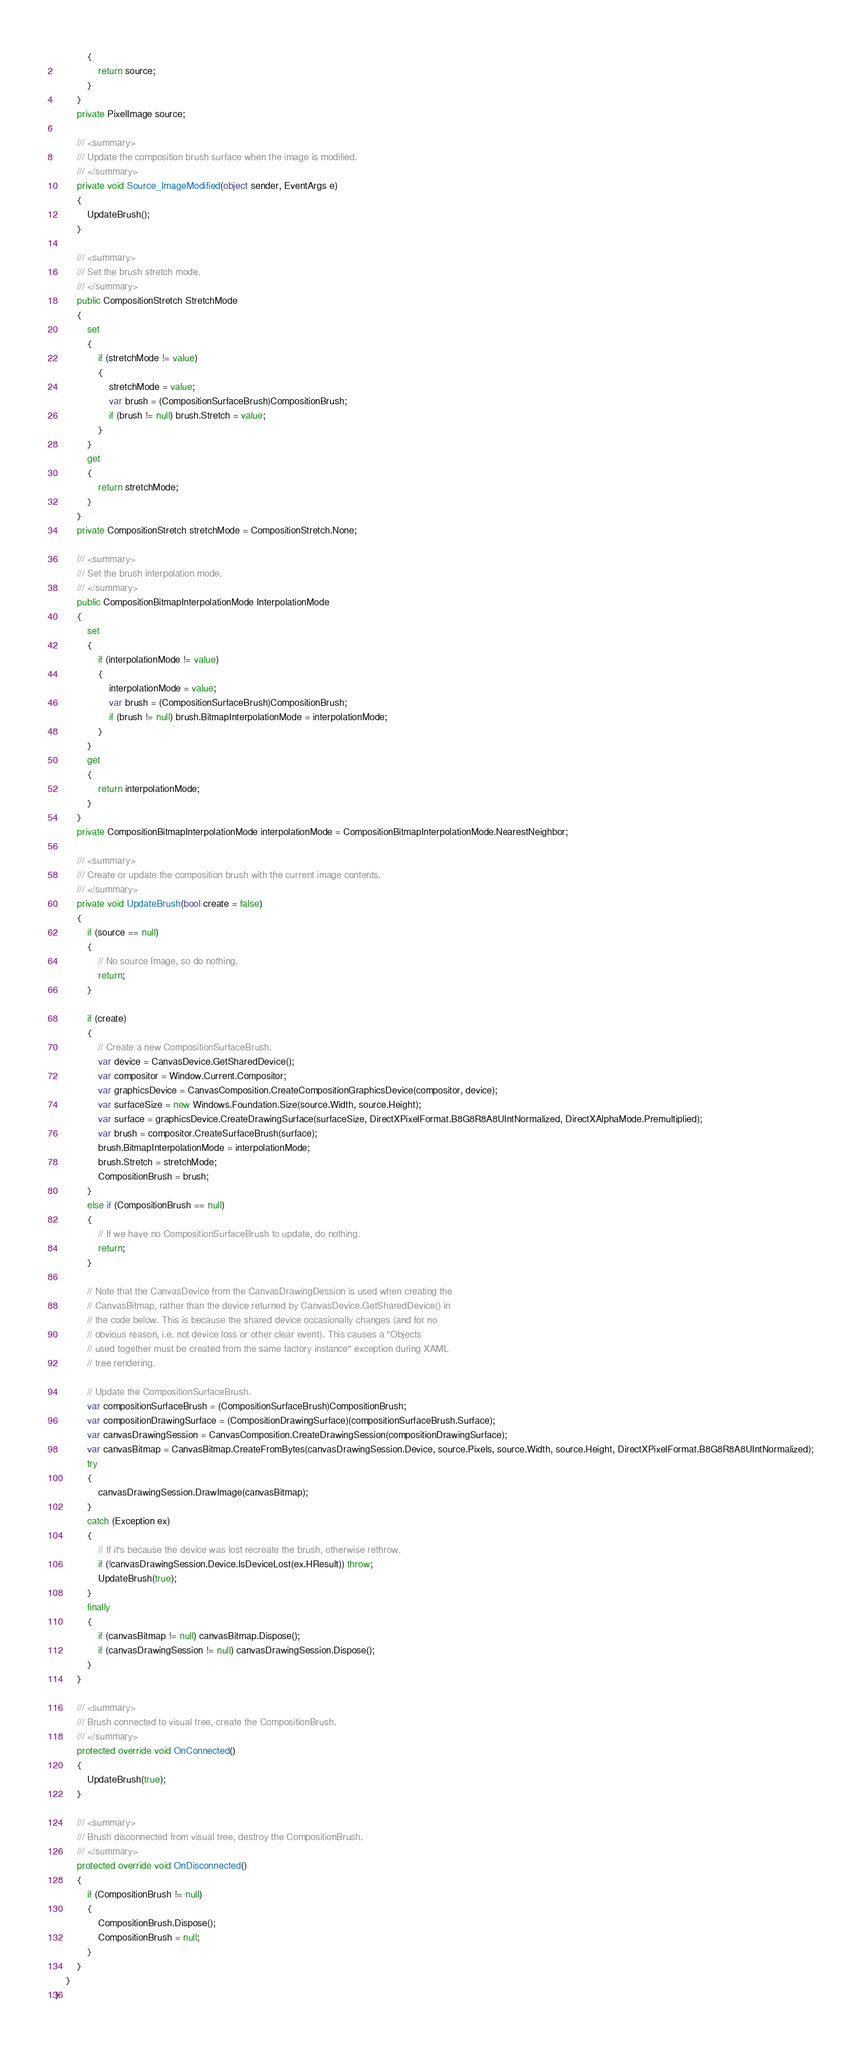<code> <loc_0><loc_0><loc_500><loc_500><_C#_>            {
                return source;
            }
        }
        private PixelImage source;

        /// <summary>
        /// Update the composition brush surface when the image is modified.
        /// </summary>
        private void Source_ImageModified(object sender, EventArgs e)
        {
            UpdateBrush();
        }

        /// <summary>
        /// Set the brush stretch mode.
        /// </summary>
        public CompositionStretch StretchMode
        {
            set
            {
                if (stretchMode != value)
                {
                    stretchMode = value;
                    var brush = (CompositionSurfaceBrush)CompositionBrush;
                    if (brush != null) brush.Stretch = value;
                }
            }
            get
            {
                return stretchMode;
            }
        }
        private CompositionStretch stretchMode = CompositionStretch.None;

        /// <summary>
        /// Set the brush interpolation mode.
        /// </summary>
        public CompositionBitmapInterpolationMode InterpolationMode
        {
            set
            {
                if (interpolationMode != value)
                {
                    interpolationMode = value;
                    var brush = (CompositionSurfaceBrush)CompositionBrush;
                    if (brush != null) brush.BitmapInterpolationMode = interpolationMode;
                }
            }
            get
            {
                return interpolationMode;
            }
        }
        private CompositionBitmapInterpolationMode interpolationMode = CompositionBitmapInterpolationMode.NearestNeighbor;

        /// <summary>
        /// Create or update the composition brush with the current image contents.
        /// </summary>
        private void UpdateBrush(bool create = false)
        {
            if (source == null)
            {
                // No source Image, so do nothing.
                return;
            }

            if (create)
            {
                // Create a new CompositionSurfaceBrush.
                var device = CanvasDevice.GetSharedDevice();
                var compositor = Window.Current.Compositor;
                var graphicsDevice = CanvasComposition.CreateCompositionGraphicsDevice(compositor, device);
                var surfaceSize = new Windows.Foundation.Size(source.Width, source.Height);
                var surface = graphicsDevice.CreateDrawingSurface(surfaceSize, DirectXPixelFormat.B8G8R8A8UIntNormalized, DirectXAlphaMode.Premultiplied);
                var brush = compositor.CreateSurfaceBrush(surface);
                brush.BitmapInterpolationMode = interpolationMode;
                brush.Stretch = stretchMode;
                CompositionBrush = brush;
            }
            else if (CompositionBrush == null)
            {
                // If we have no CompositionSurfaceBrush to update, do nothing.
                return;
            }

            // Note that the CanvasDevice from the CanvasDrawingDession is used when creating the
            // CanvasBitmap, rather than the device returned by CanvasDevice.GetSharedDevice() in
            // the code below. This is because the shared device occasionally changes (and for no
            // obvious reason, i.e. not device loss or other clear event). This causes a "Objects
            // used together must be created from the same factory instance" exception during XAML
            // tree rendering.

            // Update the CompositionSurfaceBrush.
            var compositionSurfaceBrush = (CompositionSurfaceBrush)CompositionBrush;
            var compositionDrawingSurface = (CompositionDrawingSurface)(compositionSurfaceBrush.Surface);
            var canvasDrawingSession = CanvasComposition.CreateDrawingSession(compositionDrawingSurface);
            var canvasBitmap = CanvasBitmap.CreateFromBytes(canvasDrawingSession.Device, source.Pixels, source.Width, source.Height, DirectXPixelFormat.B8G8R8A8UIntNormalized);
            try
            {
                canvasDrawingSession.DrawImage(canvasBitmap);
            }
            catch (Exception ex)
            {
                // If it's because the device was lost recreate the brush, otherwise rethrow.
                if (!canvasDrawingSession.Device.IsDeviceLost(ex.HResult)) throw;
                UpdateBrush(true);
            }
            finally
            {
                if (canvasBitmap != null) canvasBitmap.Dispose();
                if (canvasDrawingSession != null) canvasDrawingSession.Dispose();
            }
        }

        /// <summary>
        /// Brush connected to visual tree, create the CompositionBrush.
        /// </summary>
        protected override void OnConnected()
        {
            UpdateBrush(true);
        }

        /// <summary>
        /// Brush disconnected from visual tree, destroy the CompositionBrush.
        /// </summary>
        protected override void OnDisconnected()
        {
            if (CompositionBrush != null)
            {
                CompositionBrush.Dispose();
                CompositionBrush = null;
            }
        }
    }
}
</code> 